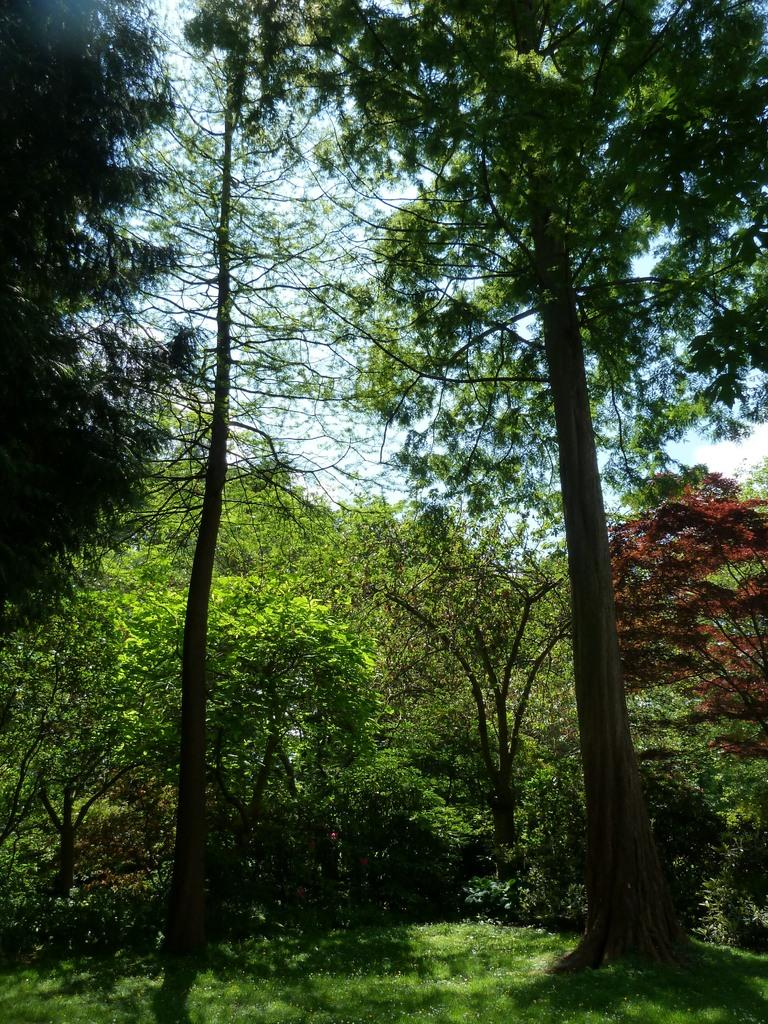What type of vegetation can be seen in the image? There are trees and plants in the image. What is covering the ground in the image? There is grass on the floor in the image. Where is the camp located in the image? There is no camp present in the image. What type of box can be seen in the image? There is no box present in the image. 